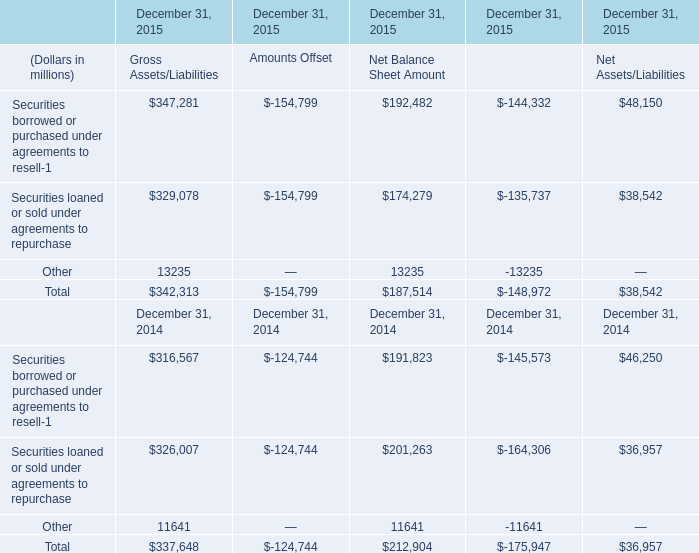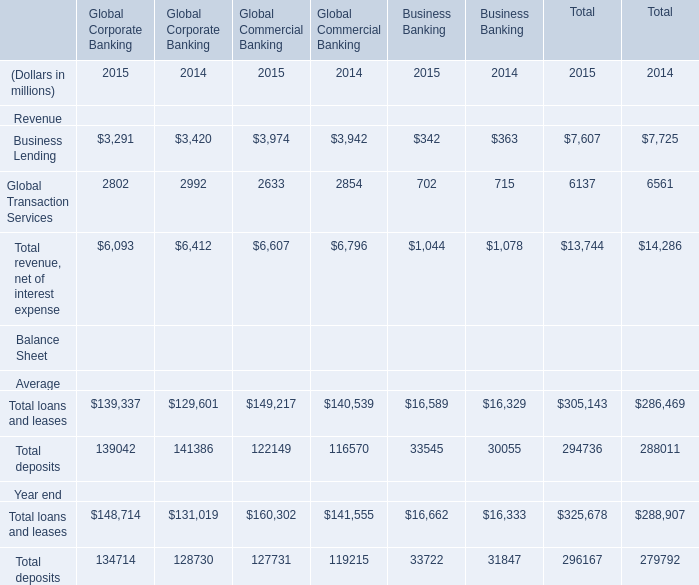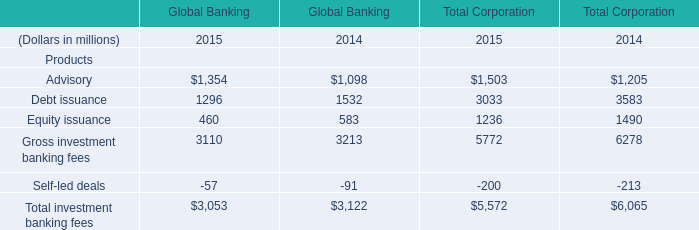In the year with the most Total loans and leases for Global Corporate Banking, what is the growth rate of Global Transaction Services in table 1? 
Computations: ((2992 - 2802) / 2992)
Answer: 0.0635. 